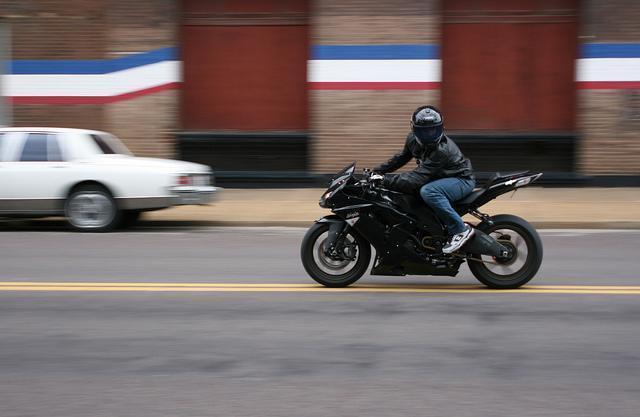Which former country had a flag which looks similar to these banners?
From the following four choices, select the correct answer to address the question.
Options: Czechoslovakia, zaire, yugoslavia, rhodesia. Yugoslavia. 